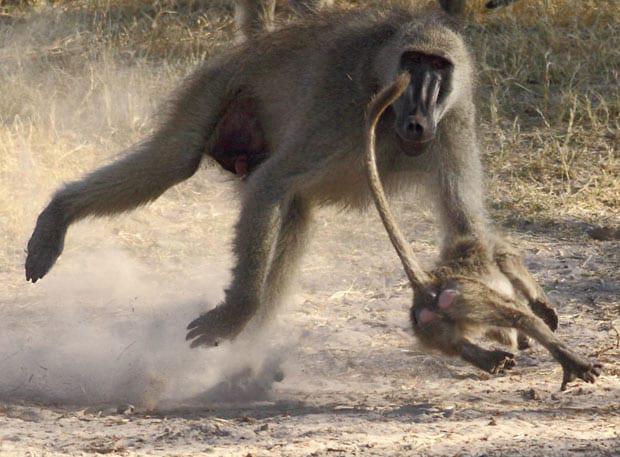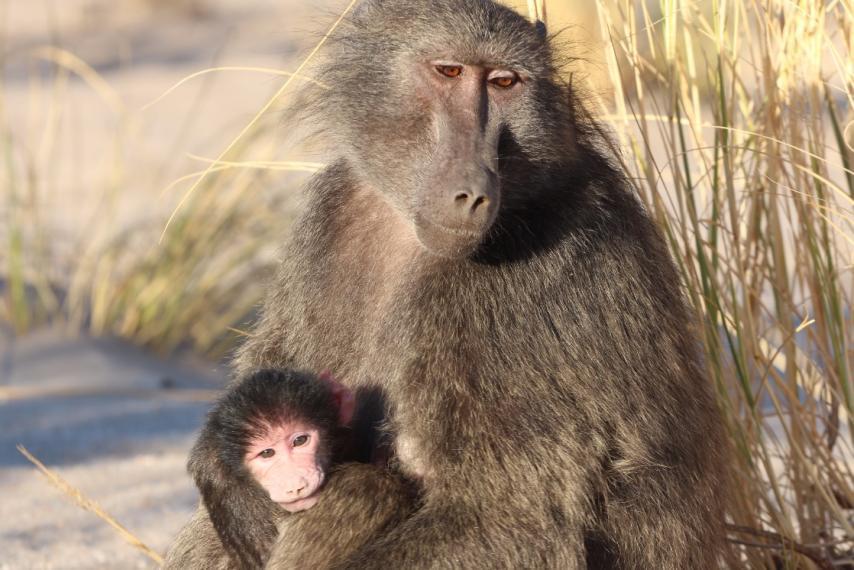The first image is the image on the left, the second image is the image on the right. Given the left and right images, does the statement "One of the images features two mandrils; mom and baby." hold true? Answer yes or no. Yes. The first image is the image on the left, the second image is the image on the right. Assess this claim about the two images: "There is no more than one baboon in the left image.". Correct or not? Answer yes or no. No. 